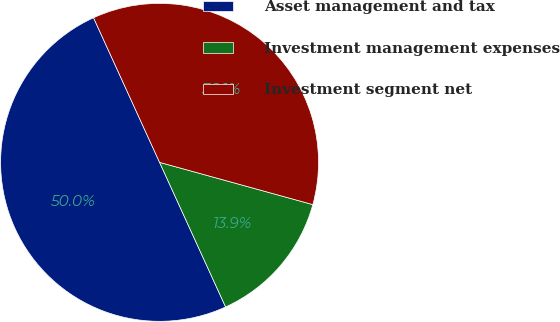Convert chart to OTSL. <chart><loc_0><loc_0><loc_500><loc_500><pie_chart><fcel>Asset management and tax<fcel>Investment management expenses<fcel>Investment segment net<nl><fcel>50.0%<fcel>13.9%<fcel>36.1%<nl></chart> 